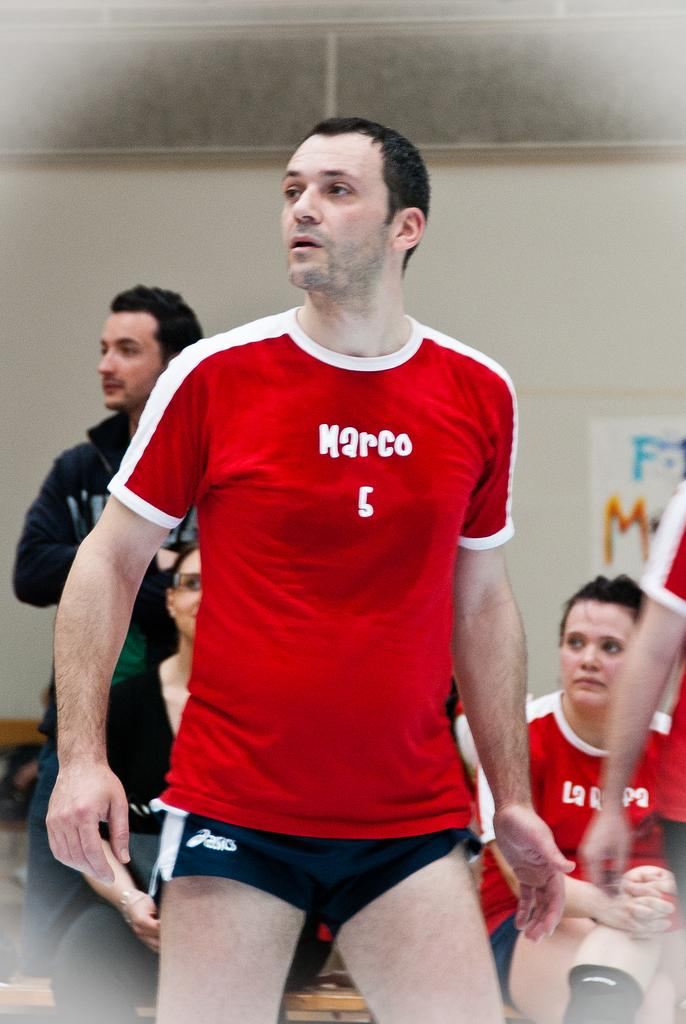<image>
Present a compact description of the photo's key features. A guy playing in a game with a red shirt that says Marco 5 on the front. 